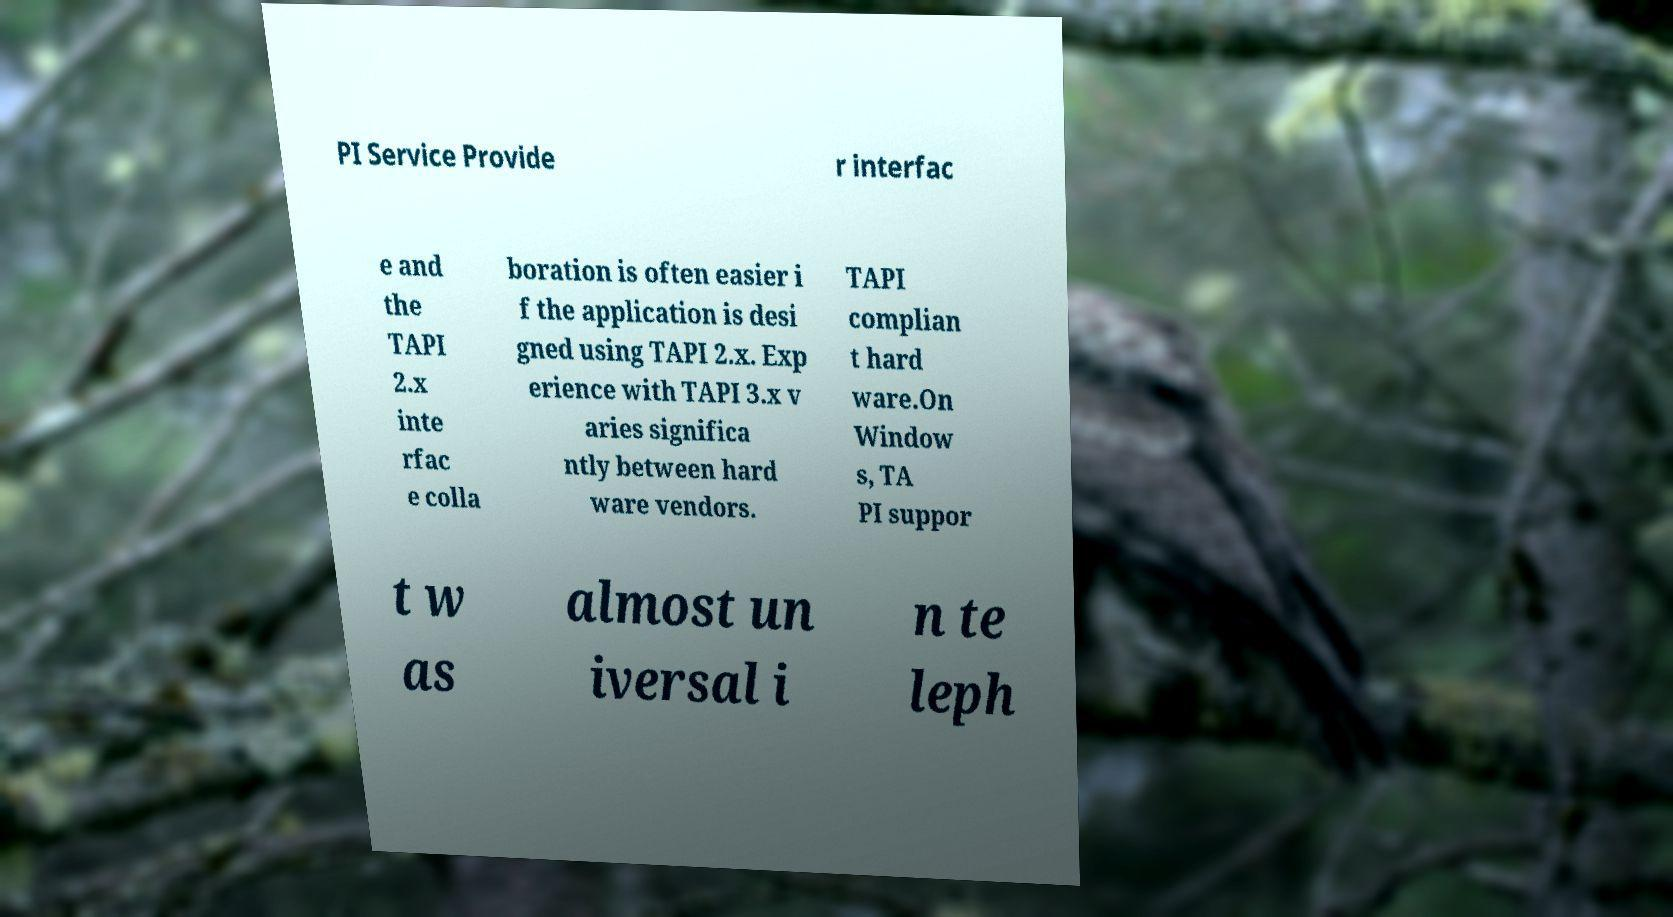What messages or text are displayed in this image? I need them in a readable, typed format. PI Service Provide r interfac e and the TAPI 2.x inte rfac e colla boration is often easier i f the application is desi gned using TAPI 2.x. Exp erience with TAPI 3.x v aries significa ntly between hard ware vendors. TAPI complian t hard ware.On Window s, TA PI suppor t w as almost un iversal i n te leph 